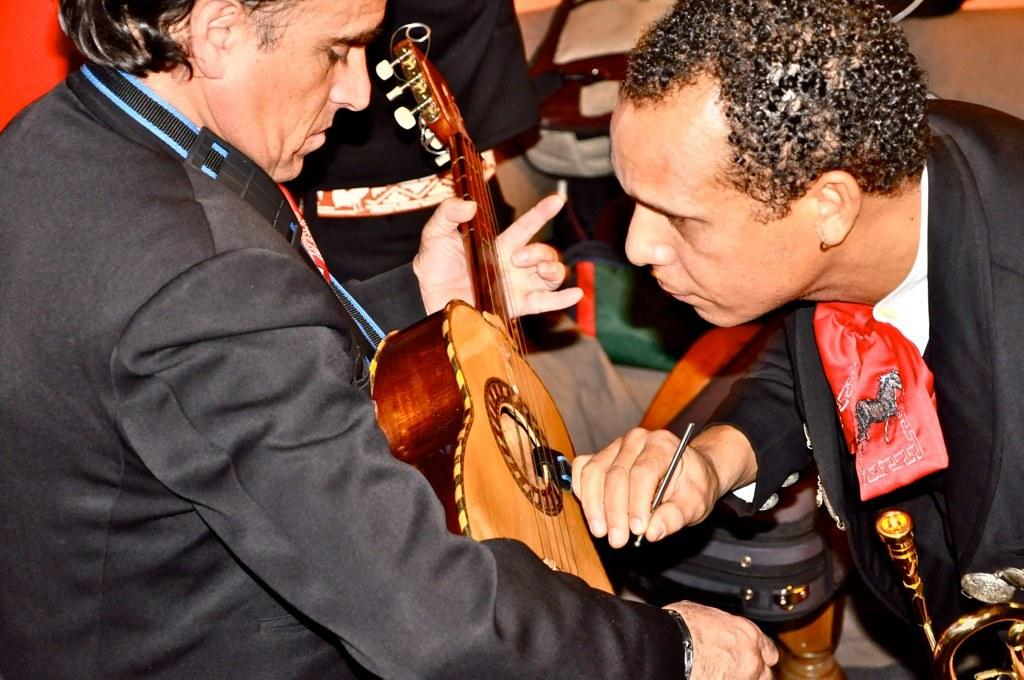What is the main activity of the person in the image? The main activity of the person in the image is singing. What instrument is the singer playing? The singer is playing a guitar. What is the other person in the image doing? The other person is catching something in the image. Can you describe the setting of the image? There are many people standing in the background. Where is the throne located in the image? There is no throne present in the image. What type of bird can be seen flying in the background? There are no birds visible in the image. 